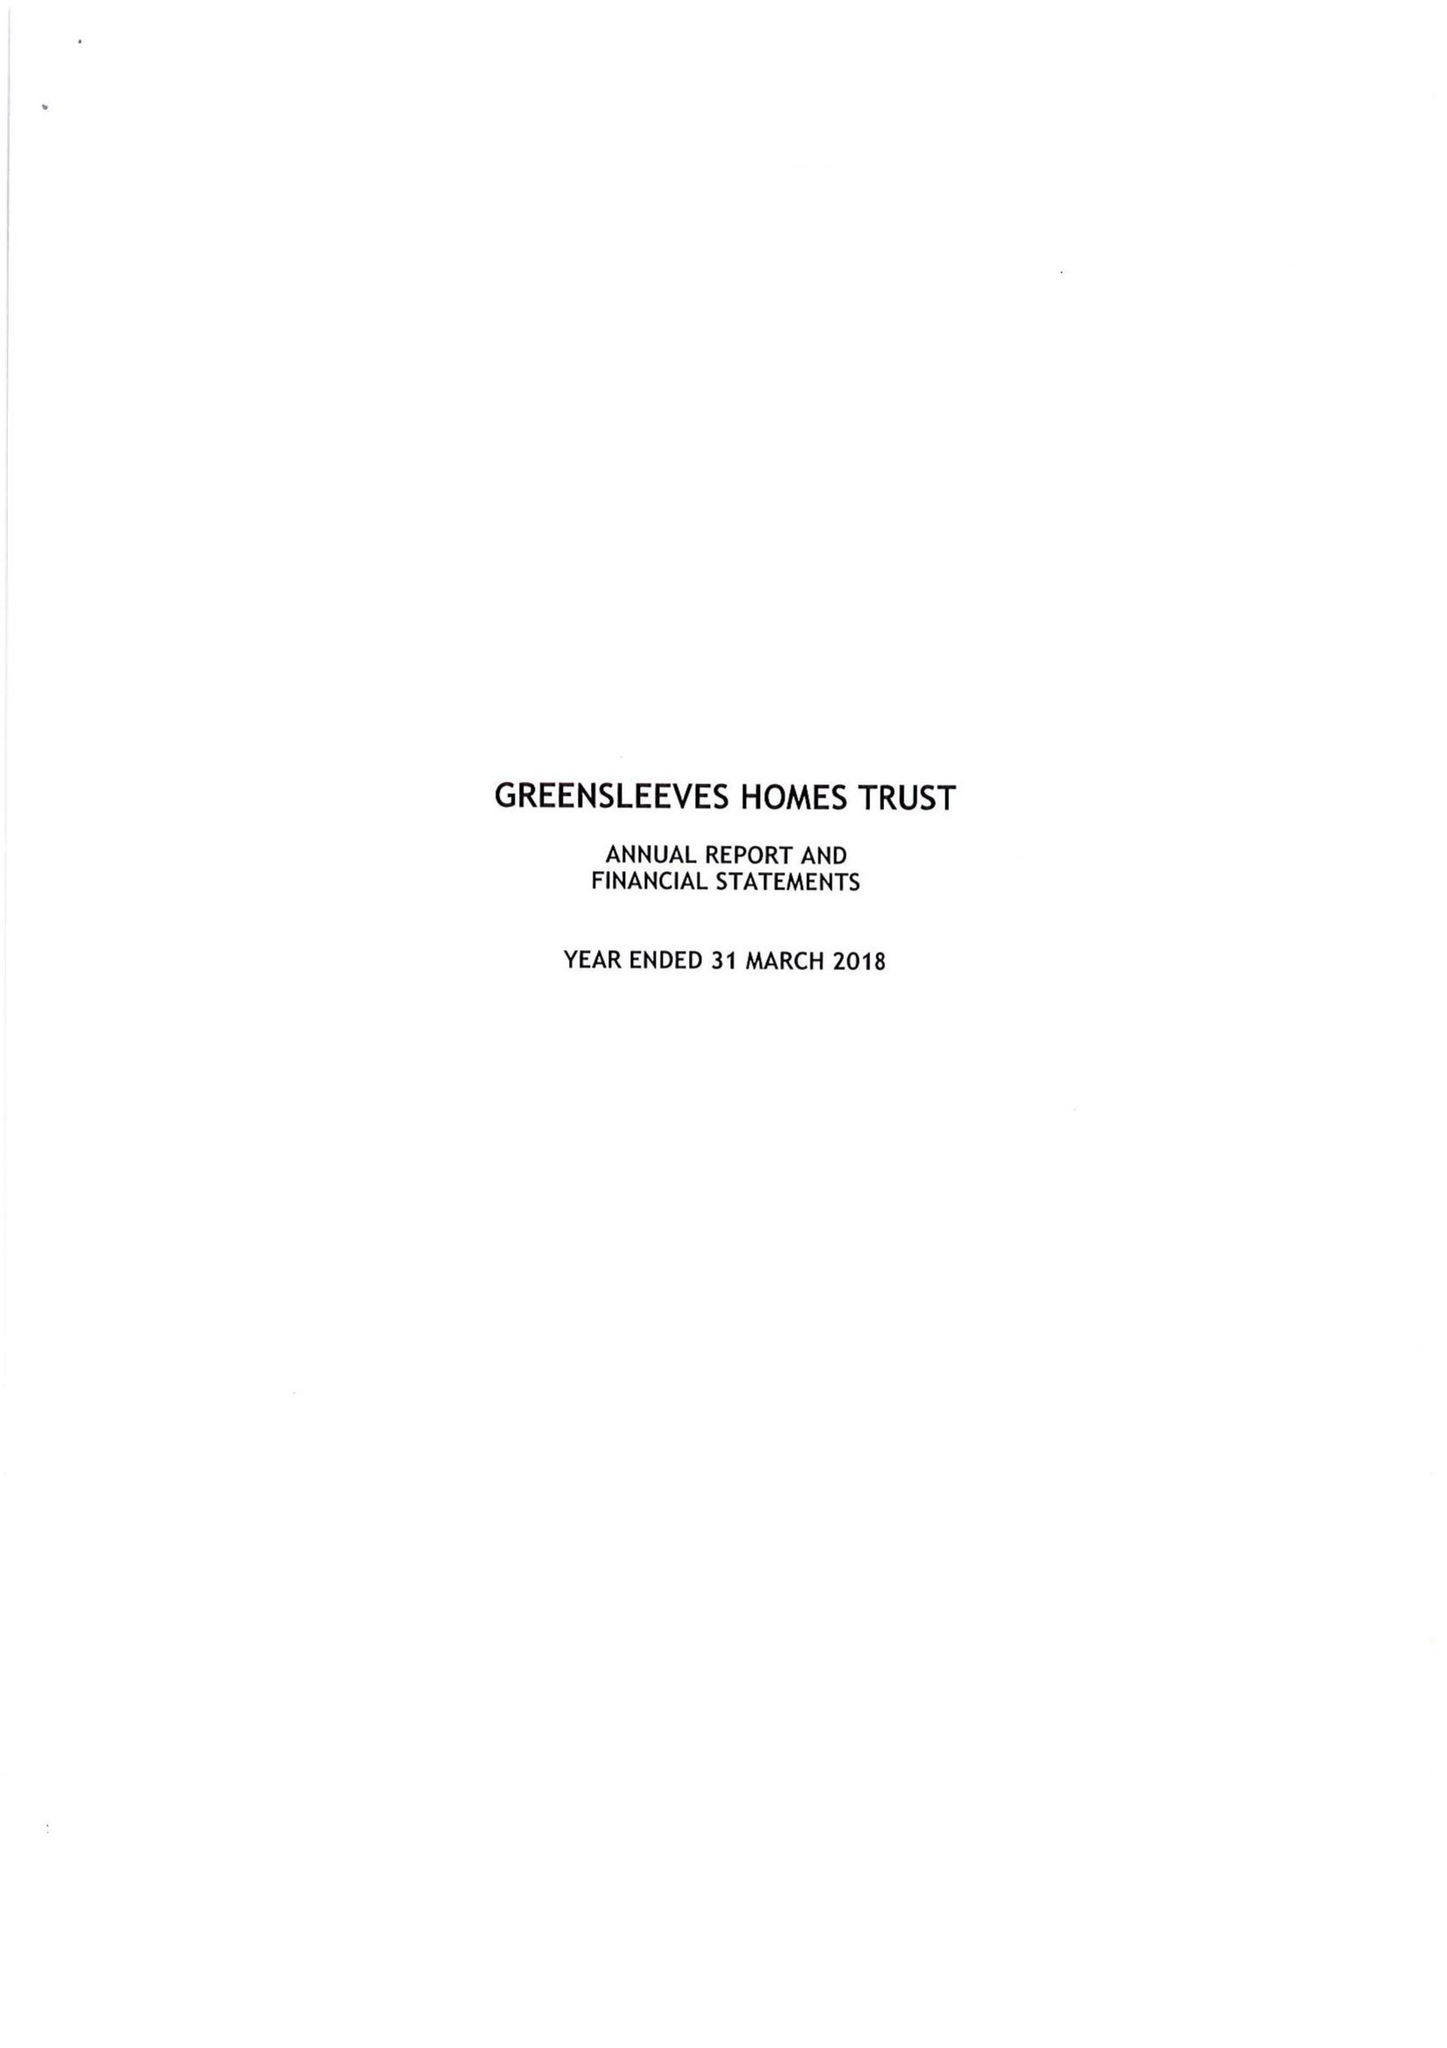What is the value for the address__postcode?
Answer the question using a single word or phrase. EC3M 3JY 